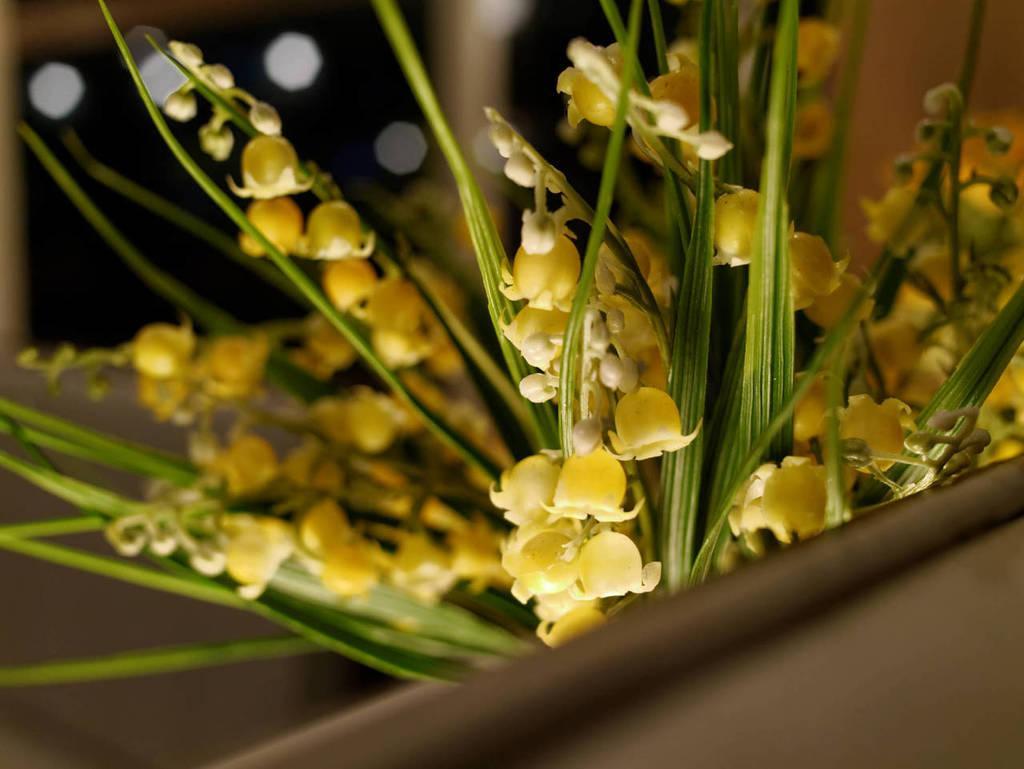How would you summarize this image in a sentence or two? In this image, we can see some plants, flowers. We can also see the blurred background. We can also see some object in the bottom right corner. 